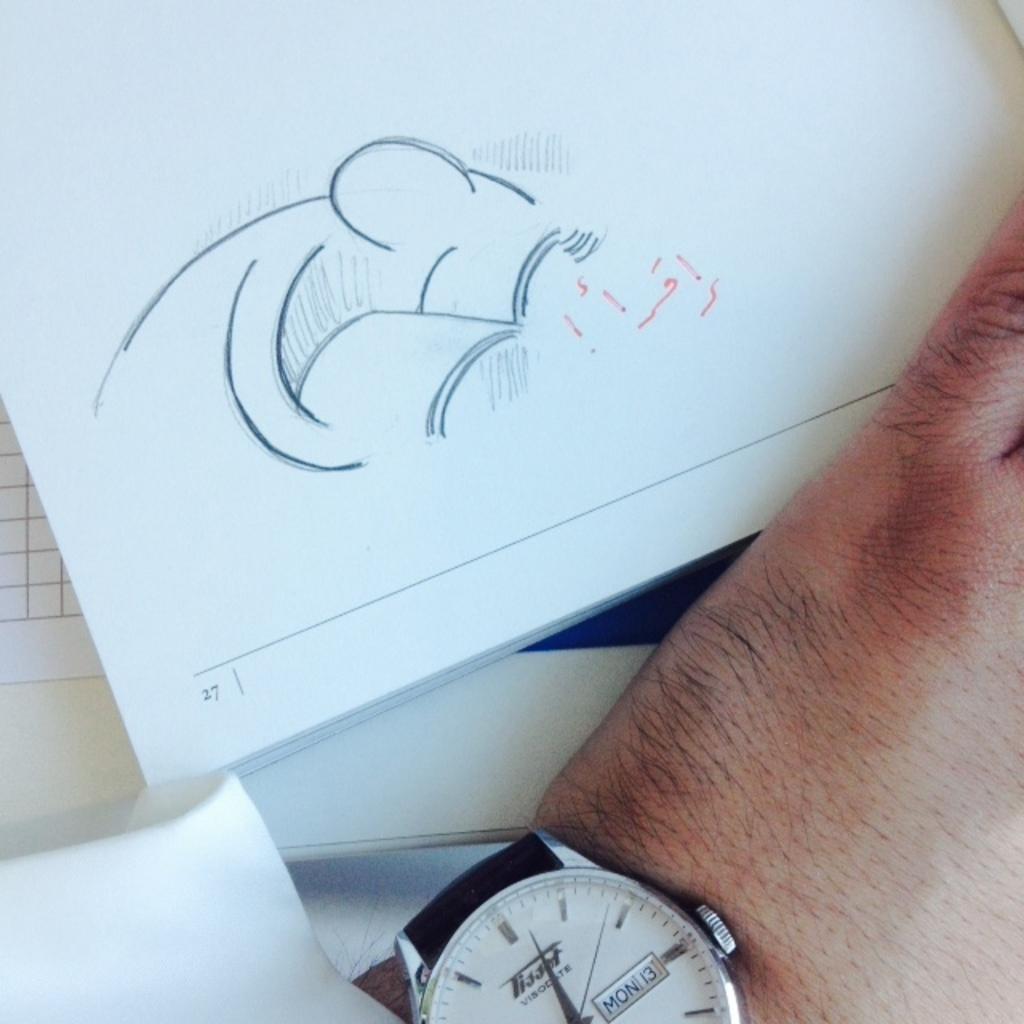What page number is this?
Provide a succinct answer. 27. 